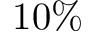<formula> <loc_0><loc_0><loc_500><loc_500>1 0 \%</formula> 